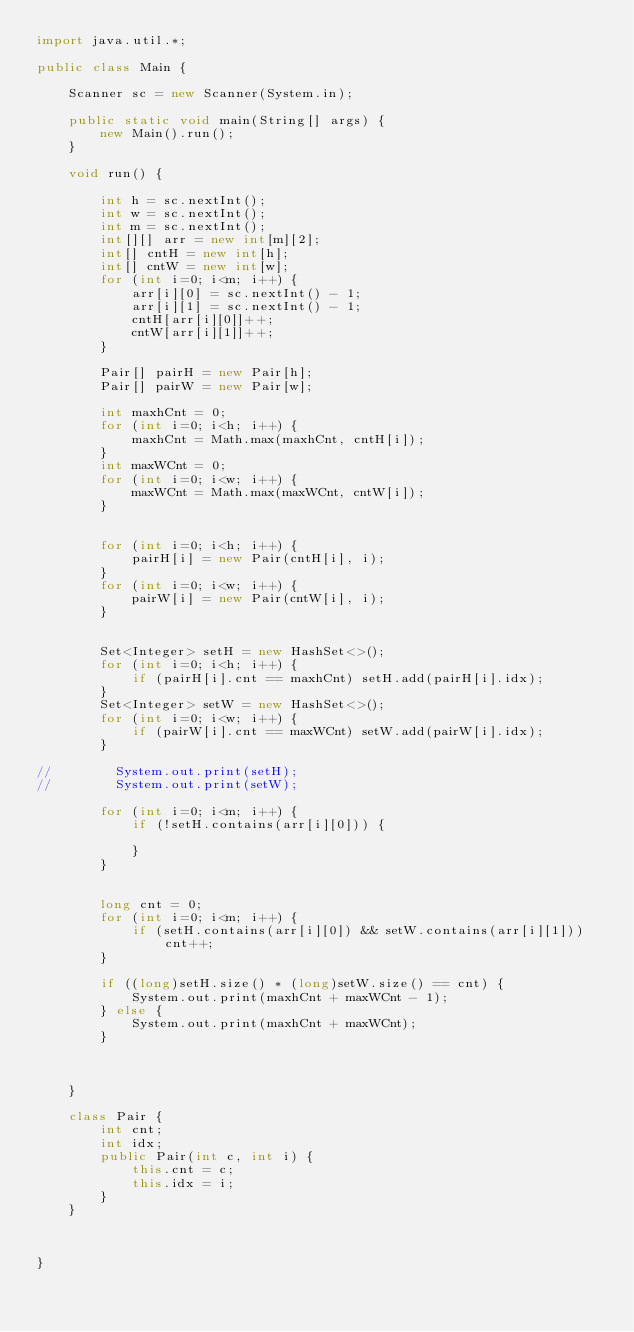Convert code to text. <code><loc_0><loc_0><loc_500><loc_500><_Java_>import java.util.*;

public class Main {

    Scanner sc = new Scanner(System.in);

    public static void main(String[] args) {
        new Main().run();
    }

    void run() {

        int h = sc.nextInt();
        int w = sc.nextInt();
        int m = sc.nextInt();
        int[][] arr = new int[m][2];
        int[] cntH = new int[h];
        int[] cntW = new int[w];
        for (int i=0; i<m; i++) {
            arr[i][0] = sc.nextInt() - 1;
            arr[i][1] = sc.nextInt() - 1;
            cntH[arr[i][0]]++;
            cntW[arr[i][1]]++;
        }

        Pair[] pairH = new Pair[h];
        Pair[] pairW = new Pair[w];

        int maxhCnt = 0;
        for (int i=0; i<h; i++) {
            maxhCnt = Math.max(maxhCnt, cntH[i]);
        }
        int maxWCnt = 0;
        for (int i=0; i<w; i++) {
            maxWCnt = Math.max(maxWCnt, cntW[i]);
        }


        for (int i=0; i<h; i++) {
            pairH[i] = new Pair(cntH[i], i);
        }
        for (int i=0; i<w; i++) {
            pairW[i] = new Pair(cntW[i], i);
        }


        Set<Integer> setH = new HashSet<>();
        for (int i=0; i<h; i++) {
            if (pairH[i].cnt == maxhCnt) setH.add(pairH[i].idx);
        }
        Set<Integer> setW = new HashSet<>();
        for (int i=0; i<w; i++) {
            if (pairW[i].cnt == maxWCnt) setW.add(pairW[i].idx);
        }

//        System.out.print(setH);
//        System.out.print(setW);

        for (int i=0; i<m; i++) {
            if (!setH.contains(arr[i][0])) {

            }
        }


        long cnt = 0;
        for (int i=0; i<m; i++) {
            if (setH.contains(arr[i][0]) && setW.contains(arr[i][1])) cnt++;
        }

        if ((long)setH.size() * (long)setW.size() == cnt) {
            System.out.print(maxhCnt + maxWCnt - 1);
        } else {
            System.out.print(maxhCnt + maxWCnt);
        }



    }

    class Pair {
        int cnt;
        int idx;
        public Pair(int c, int i) {
            this.cnt = c;
            this.idx = i;
        }
    }



}

</code> 